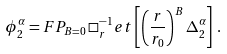Convert formula to latex. <formula><loc_0><loc_0><loc_500><loc_500>\phi _ { 2 } ^ { \alpha } = F P _ { B = 0 } \, \Box ^ { - 1 } _ { r } e t \left [ \left ( \frac { r } { r _ { 0 } } \right ) ^ { B } \Delta _ { 2 } ^ { \alpha } \right ] \, .</formula> 